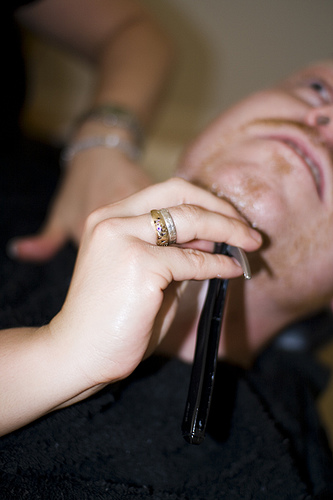<image>
Is there a hammer thing in the person? No. The hammer thing is not contained within the person. These objects have a different spatial relationship. 